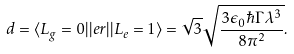Convert formula to latex. <formula><loc_0><loc_0><loc_500><loc_500>d = \langle L _ { g } = 0 | | e r | | L _ { e } = 1 \rangle = \sqrt { 3 } \sqrt { \frac { 3 \epsilon _ { 0 } \hbar { \Gamma } \lambda ^ { 3 } } { 8 \pi ^ { 2 } } } .</formula> 